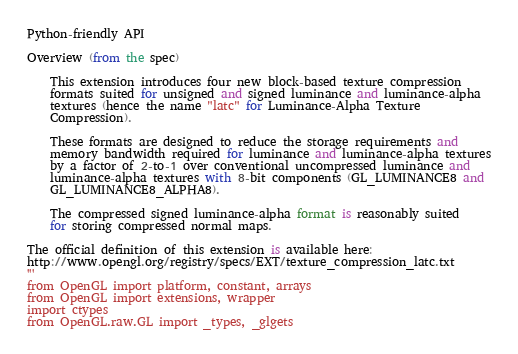<code> <loc_0><loc_0><loc_500><loc_500><_Python_>Python-friendly API

Overview (from the spec)
	
	This extension introduces four new block-based texture compression
	formats suited for unsigned and signed luminance and luminance-alpha
	textures (hence the name "latc" for Luminance-Alpha Texture
	Compression).
	
	These formats are designed to reduce the storage requirements and
	memory bandwidth required for luminance and luminance-alpha textures
	by a factor of 2-to-1 over conventional uncompressed luminance and
	luminance-alpha textures with 8-bit components (GL_LUMINANCE8 and
	GL_LUMINANCE8_ALPHA8).
	
	The compressed signed luminance-alpha format is reasonably suited
	for storing compressed normal maps.

The official definition of this extension is available here:
http://www.opengl.org/registry/specs/EXT/texture_compression_latc.txt
'''
from OpenGL import platform, constant, arrays
from OpenGL import extensions, wrapper
import ctypes
from OpenGL.raw.GL import _types, _glgets</code> 